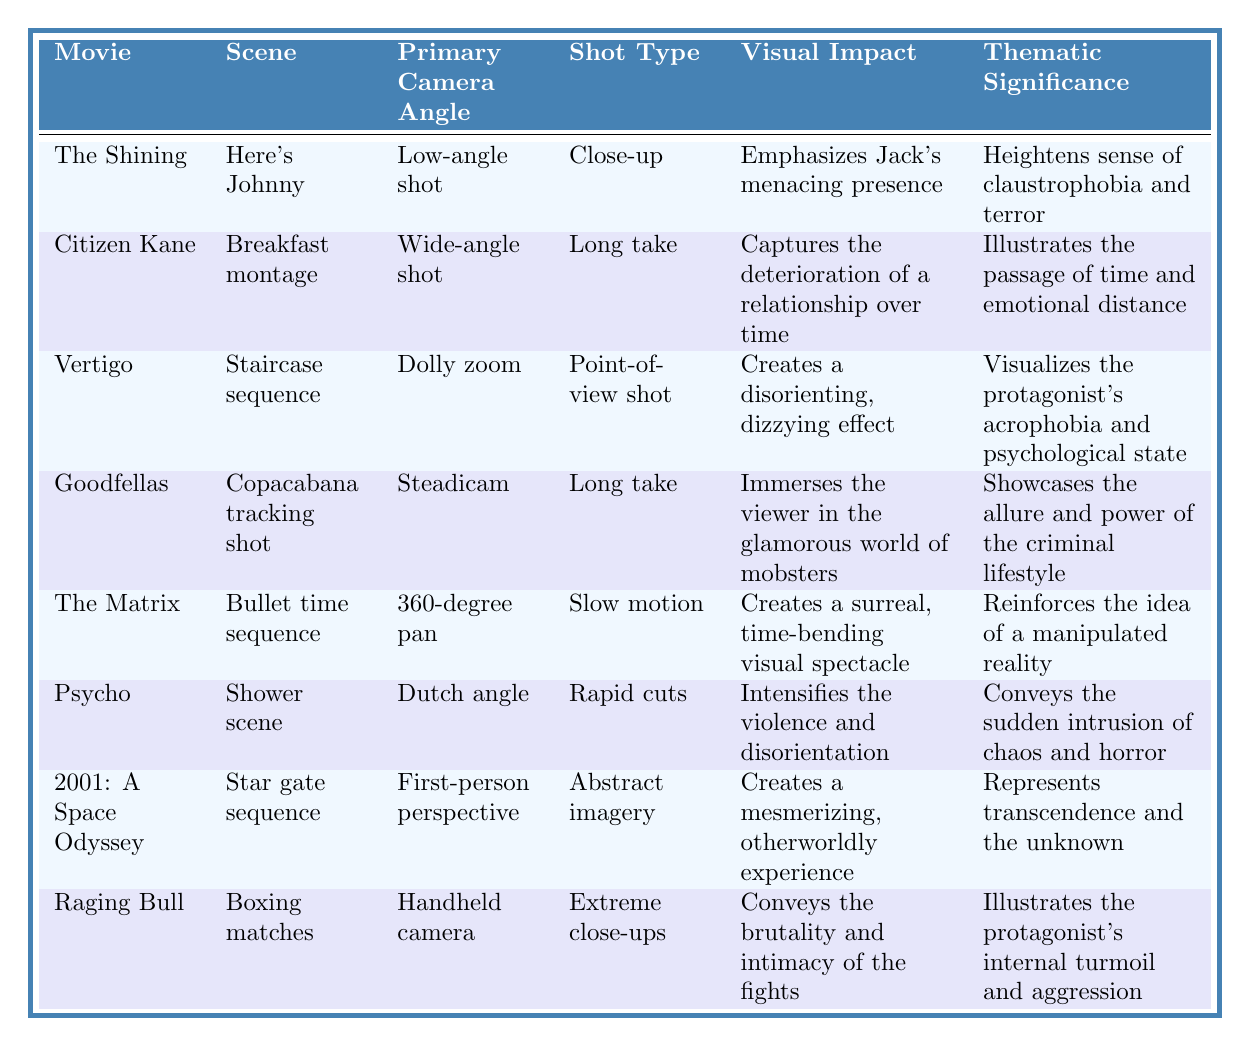What primary camera angle is used in "The Shining"? The table lists "The Shining" under the movie column and shows the primary camera angle for that scene is a "Low-angle shot".
Answer: Low-angle shot Which movie features a 360-degree pan camera angle? In the table, "The Matrix" is indicated to use a "360-degree pan" as its primary camera angle for the bullet time sequence.
Answer: The Matrix How many scenes utilized a long take as their shot type? By scanning the table, "Citizen Kane" and "Goodfellas" are the two scenes that have "Long take" as their shot type, so there are two.
Answer: 2 In which scene does the camera angle create a surreal visual experience? The table states that in "The Matrix" during the "Bullet time sequence", the camera angle and shot create a surreal, time-bending visual spectacle.
Answer: Bullet time sequence Is the primary camera angle in "Psycho" a Dutch angle? The table shows that "Psycho" indeed employs a "Dutch angle" for its shower scene, confirming the fact.
Answer: Yes Which movie's scene emphasizes a character's menacing presence? According to the table, the scene from "The Shining" with a low-angle shot and close-up emphasizes Jack's menacing presence.
Answer: The Shining Compare the thematic significance of the scenes in "Citizen Kane" and "Raging Bull". Which one reflects on the passage of time? The thematic significance of "Citizen Kane" reflects on the passage of time and emotional distance, while "Raging Bull" illustrates the protagonist's internal turmoil. Since we are looking for the one that reflects on the passage of time, it is "Citizen Kane".
Answer: Citizen Kane Which shot types employ rapid cuts? The table indicates that the shot type that employs rapid cuts is used in "Psycho" during the shower scene, which is the only instance here.
Answer: Psycho What visual impact is created in the "Boxing matches" scene of "Raging Bull"? The table states that the visual impact of the boxing matches in "Raging Bull" conveys the brutality and intimacy of the fights.
Answer: Conveys brutality and intimacy Identify the scene that uses a handheld camera and describe its thematic significance. The scene from "Raging Bull" utilizes a handheld camera, and its thematic significance illustrates the protagonist's internal turmoil and aggression.
Answer: Raging Bull, internal turmoil and aggression 